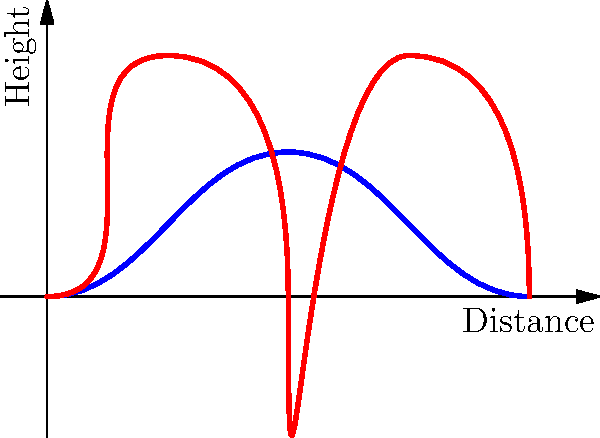As a content creator preparing for a virtual workshop on freelance business strategies, you want to include an interesting fact about human movement. Examining the biomechanical differences between walking and running gaits, which of the following statements is true?

A) Walking has a double support phase, while running has a flight phase
B) Running consumes less energy than walking at all speeds
C) The vertical ground reaction force in walking always exceeds body weight
D) The stance phase duration is longer in running compared to walking Let's analyze the biomechanical differences between walking and running gaits:

1. Support phases:
   - Walking: Has a double support phase where both feet are in contact with the ground.
   - Running: Has a flight phase where neither foot is in contact with the ground.

2. Energy consumption:
   - Walking is more energy-efficient at lower speeds.
   - Running becomes more energy-efficient at higher speeds (typically above 4-5 mph).

3. Vertical ground reaction force (vGRF):
   - Walking: vGRF typically has two peaks, each less than body weight.
   - Running: vGRF has a single peak that exceeds body weight.

4. Stance phase duration:
   - Walking: Stance phase is longer, typically 60-65% of the gait cycle.
   - Running: Stance phase is shorter, typically 30-35% of the gait cycle.

5. Leg mechanics:
   - Walking: Legs act more like inverted pendulums.
   - Running: Legs act more like springs, with greater knee flexion and ankle dorsiflexion.

6. Step length and frequency:
   - Running generally has longer step lengths and higher step frequencies compared to walking.

Based on these biomechanical differences, the correct statement is option A. Walking has a double support phase where both feet are in contact with the ground, while running has a flight phase where neither foot is in contact with the ground. This is clearly illustrated in the provided graph, where the walking gait (blue line) shows a smoother, more continuous path, while the running gait (red line) shows distinct arcs with gaps between them, representing the flight phase.
Answer: A) Walking has a double support phase, while running has a flight phase 